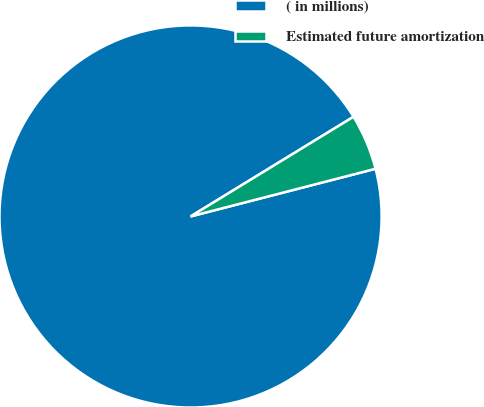<chart> <loc_0><loc_0><loc_500><loc_500><pie_chart><fcel>( in millions)<fcel>Estimated future amortization<nl><fcel>95.28%<fcel>4.72%<nl></chart> 